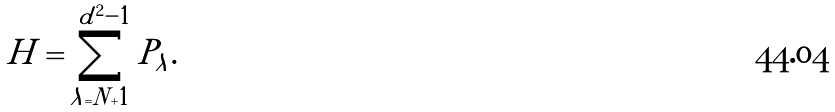Convert formula to latex. <formula><loc_0><loc_0><loc_500><loc_500>H = \sum _ { \lambda = N + 1 } ^ { d ^ { 2 } - 1 } P _ { \lambda } .</formula> 